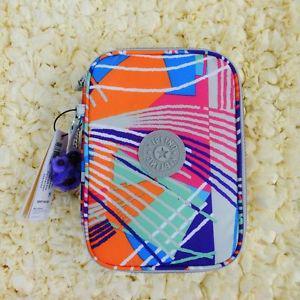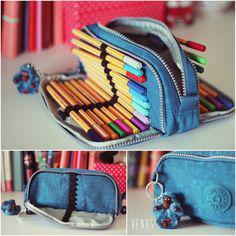The first image is the image on the left, the second image is the image on the right. For the images displayed, is the sentence "A blue pencil case is holding several pencils." factually correct? Answer yes or no. Yes. 